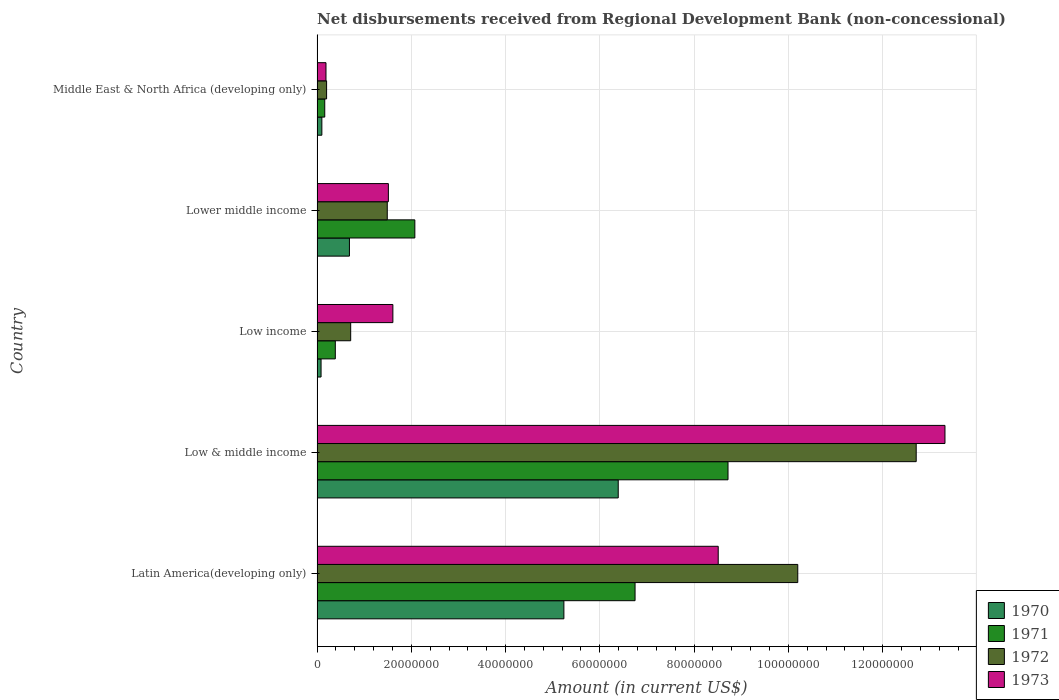How many groups of bars are there?
Give a very brief answer. 5. How many bars are there on the 5th tick from the top?
Provide a succinct answer. 4. What is the amount of disbursements received from Regional Development Bank in 1970 in Lower middle income?
Your response must be concise. 6.87e+06. Across all countries, what is the maximum amount of disbursements received from Regional Development Bank in 1970?
Make the answer very short. 6.39e+07. Across all countries, what is the minimum amount of disbursements received from Regional Development Bank in 1973?
Ensure brevity in your answer.  1.90e+06. In which country was the amount of disbursements received from Regional Development Bank in 1973 maximum?
Keep it short and to the point. Low & middle income. What is the total amount of disbursements received from Regional Development Bank in 1972 in the graph?
Your answer should be compact. 2.53e+08. What is the difference between the amount of disbursements received from Regional Development Bank in 1972 in Low & middle income and that in Lower middle income?
Your answer should be compact. 1.12e+08. What is the difference between the amount of disbursements received from Regional Development Bank in 1972 in Low income and the amount of disbursements received from Regional Development Bank in 1971 in Low & middle income?
Provide a succinct answer. -8.01e+07. What is the average amount of disbursements received from Regional Development Bank in 1971 per country?
Provide a short and direct response. 3.62e+07. What is the difference between the amount of disbursements received from Regional Development Bank in 1972 and amount of disbursements received from Regional Development Bank in 1971 in Middle East & North Africa (developing only)?
Your answer should be compact. 3.89e+05. What is the ratio of the amount of disbursements received from Regional Development Bank in 1972 in Lower middle income to that in Middle East & North Africa (developing only)?
Your answer should be compact. 7.36. Is the amount of disbursements received from Regional Development Bank in 1971 in Latin America(developing only) less than that in Low & middle income?
Your response must be concise. Yes. What is the difference between the highest and the second highest amount of disbursements received from Regional Development Bank in 1972?
Make the answer very short. 2.51e+07. What is the difference between the highest and the lowest amount of disbursements received from Regional Development Bank in 1971?
Your answer should be compact. 8.56e+07. Is the sum of the amount of disbursements received from Regional Development Bank in 1973 in Low & middle income and Low income greater than the maximum amount of disbursements received from Regional Development Bank in 1970 across all countries?
Your answer should be compact. Yes. Is it the case that in every country, the sum of the amount of disbursements received from Regional Development Bank in 1971 and amount of disbursements received from Regional Development Bank in 1970 is greater than the sum of amount of disbursements received from Regional Development Bank in 1973 and amount of disbursements received from Regional Development Bank in 1972?
Offer a very short reply. No. Is it the case that in every country, the sum of the amount of disbursements received from Regional Development Bank in 1973 and amount of disbursements received from Regional Development Bank in 1972 is greater than the amount of disbursements received from Regional Development Bank in 1970?
Offer a terse response. Yes. Are all the bars in the graph horizontal?
Offer a terse response. Yes. How many countries are there in the graph?
Make the answer very short. 5. What is the difference between two consecutive major ticks on the X-axis?
Give a very brief answer. 2.00e+07. Does the graph contain any zero values?
Keep it short and to the point. No. Where does the legend appear in the graph?
Offer a terse response. Bottom right. How many legend labels are there?
Keep it short and to the point. 4. What is the title of the graph?
Make the answer very short. Net disbursements received from Regional Development Bank (non-concessional). What is the Amount (in current US$) in 1970 in Latin America(developing only)?
Provide a short and direct response. 5.24e+07. What is the Amount (in current US$) of 1971 in Latin America(developing only)?
Offer a terse response. 6.75e+07. What is the Amount (in current US$) of 1972 in Latin America(developing only)?
Ensure brevity in your answer.  1.02e+08. What is the Amount (in current US$) of 1973 in Latin America(developing only)?
Provide a short and direct response. 8.51e+07. What is the Amount (in current US$) of 1970 in Low & middle income?
Provide a succinct answer. 6.39e+07. What is the Amount (in current US$) in 1971 in Low & middle income?
Provide a succinct answer. 8.72e+07. What is the Amount (in current US$) of 1972 in Low & middle income?
Keep it short and to the point. 1.27e+08. What is the Amount (in current US$) in 1973 in Low & middle income?
Your answer should be compact. 1.33e+08. What is the Amount (in current US$) in 1970 in Low income?
Make the answer very short. 8.50e+05. What is the Amount (in current US$) in 1971 in Low income?
Make the answer very short. 3.88e+06. What is the Amount (in current US$) of 1972 in Low income?
Your answer should be very brief. 7.14e+06. What is the Amount (in current US$) of 1973 in Low income?
Provide a succinct answer. 1.61e+07. What is the Amount (in current US$) of 1970 in Lower middle income?
Provide a succinct answer. 6.87e+06. What is the Amount (in current US$) of 1971 in Lower middle income?
Your answer should be very brief. 2.08e+07. What is the Amount (in current US$) of 1972 in Lower middle income?
Provide a short and direct response. 1.49e+07. What is the Amount (in current US$) of 1973 in Lower middle income?
Keep it short and to the point. 1.51e+07. What is the Amount (in current US$) in 1970 in Middle East & North Africa (developing only)?
Make the answer very short. 1.02e+06. What is the Amount (in current US$) of 1971 in Middle East & North Africa (developing only)?
Your response must be concise. 1.64e+06. What is the Amount (in current US$) of 1972 in Middle East & North Africa (developing only)?
Give a very brief answer. 2.02e+06. What is the Amount (in current US$) in 1973 in Middle East & North Africa (developing only)?
Give a very brief answer. 1.90e+06. Across all countries, what is the maximum Amount (in current US$) in 1970?
Make the answer very short. 6.39e+07. Across all countries, what is the maximum Amount (in current US$) of 1971?
Provide a short and direct response. 8.72e+07. Across all countries, what is the maximum Amount (in current US$) in 1972?
Your answer should be compact. 1.27e+08. Across all countries, what is the maximum Amount (in current US$) of 1973?
Keep it short and to the point. 1.33e+08. Across all countries, what is the minimum Amount (in current US$) in 1970?
Your answer should be very brief. 8.50e+05. Across all countries, what is the minimum Amount (in current US$) of 1971?
Offer a terse response. 1.64e+06. Across all countries, what is the minimum Amount (in current US$) of 1972?
Offer a terse response. 2.02e+06. Across all countries, what is the minimum Amount (in current US$) in 1973?
Offer a terse response. 1.90e+06. What is the total Amount (in current US$) of 1970 in the graph?
Your answer should be very brief. 1.25e+08. What is the total Amount (in current US$) of 1971 in the graph?
Offer a terse response. 1.81e+08. What is the total Amount (in current US$) of 1972 in the graph?
Offer a very short reply. 2.53e+08. What is the total Amount (in current US$) of 1973 in the graph?
Make the answer very short. 2.51e+08. What is the difference between the Amount (in current US$) of 1970 in Latin America(developing only) and that in Low & middle income?
Offer a terse response. -1.15e+07. What is the difference between the Amount (in current US$) in 1971 in Latin America(developing only) and that in Low & middle income?
Keep it short and to the point. -1.97e+07. What is the difference between the Amount (in current US$) of 1972 in Latin America(developing only) and that in Low & middle income?
Offer a very short reply. -2.51e+07. What is the difference between the Amount (in current US$) of 1973 in Latin America(developing only) and that in Low & middle income?
Your answer should be very brief. -4.81e+07. What is the difference between the Amount (in current US$) in 1970 in Latin America(developing only) and that in Low income?
Your answer should be very brief. 5.15e+07. What is the difference between the Amount (in current US$) of 1971 in Latin America(developing only) and that in Low income?
Your answer should be very brief. 6.36e+07. What is the difference between the Amount (in current US$) of 1972 in Latin America(developing only) and that in Low income?
Your response must be concise. 9.49e+07. What is the difference between the Amount (in current US$) in 1973 in Latin America(developing only) and that in Low income?
Ensure brevity in your answer.  6.90e+07. What is the difference between the Amount (in current US$) in 1970 in Latin America(developing only) and that in Lower middle income?
Offer a very short reply. 4.55e+07. What is the difference between the Amount (in current US$) of 1971 in Latin America(developing only) and that in Lower middle income?
Keep it short and to the point. 4.67e+07. What is the difference between the Amount (in current US$) in 1972 in Latin America(developing only) and that in Lower middle income?
Offer a very short reply. 8.71e+07. What is the difference between the Amount (in current US$) in 1973 in Latin America(developing only) and that in Lower middle income?
Give a very brief answer. 7.00e+07. What is the difference between the Amount (in current US$) in 1970 in Latin America(developing only) and that in Middle East & North Africa (developing only)?
Give a very brief answer. 5.14e+07. What is the difference between the Amount (in current US$) in 1971 in Latin America(developing only) and that in Middle East & North Africa (developing only)?
Your answer should be very brief. 6.58e+07. What is the difference between the Amount (in current US$) of 1972 in Latin America(developing only) and that in Middle East & North Africa (developing only)?
Keep it short and to the point. 1.00e+08. What is the difference between the Amount (in current US$) of 1973 in Latin America(developing only) and that in Middle East & North Africa (developing only)?
Ensure brevity in your answer.  8.32e+07. What is the difference between the Amount (in current US$) of 1970 in Low & middle income and that in Low income?
Provide a succinct answer. 6.31e+07. What is the difference between the Amount (in current US$) of 1971 in Low & middle income and that in Low income?
Your answer should be compact. 8.33e+07. What is the difference between the Amount (in current US$) of 1972 in Low & middle income and that in Low income?
Keep it short and to the point. 1.20e+08. What is the difference between the Amount (in current US$) in 1973 in Low & middle income and that in Low income?
Offer a terse response. 1.17e+08. What is the difference between the Amount (in current US$) in 1970 in Low & middle income and that in Lower middle income?
Your answer should be very brief. 5.70e+07. What is the difference between the Amount (in current US$) in 1971 in Low & middle income and that in Lower middle income?
Your answer should be compact. 6.64e+07. What is the difference between the Amount (in current US$) of 1972 in Low & middle income and that in Lower middle income?
Offer a very short reply. 1.12e+08. What is the difference between the Amount (in current US$) of 1973 in Low & middle income and that in Lower middle income?
Offer a very short reply. 1.18e+08. What is the difference between the Amount (in current US$) in 1970 in Low & middle income and that in Middle East & North Africa (developing only)?
Give a very brief answer. 6.29e+07. What is the difference between the Amount (in current US$) in 1971 in Low & middle income and that in Middle East & North Africa (developing only)?
Offer a terse response. 8.56e+07. What is the difference between the Amount (in current US$) in 1972 in Low & middle income and that in Middle East & North Africa (developing only)?
Provide a short and direct response. 1.25e+08. What is the difference between the Amount (in current US$) of 1973 in Low & middle income and that in Middle East & North Africa (developing only)?
Your answer should be compact. 1.31e+08. What is the difference between the Amount (in current US$) of 1970 in Low income and that in Lower middle income?
Make the answer very short. -6.02e+06. What is the difference between the Amount (in current US$) in 1971 in Low income and that in Lower middle income?
Offer a terse response. -1.69e+07. What is the difference between the Amount (in current US$) of 1972 in Low income and that in Lower middle income?
Provide a succinct answer. -7.76e+06. What is the difference between the Amount (in current US$) of 1973 in Low income and that in Lower middle income?
Keep it short and to the point. 9.55e+05. What is the difference between the Amount (in current US$) of 1970 in Low income and that in Middle East & North Africa (developing only)?
Your answer should be very brief. -1.71e+05. What is the difference between the Amount (in current US$) in 1971 in Low income and that in Middle East & North Africa (developing only)?
Make the answer very short. 2.24e+06. What is the difference between the Amount (in current US$) in 1972 in Low income and that in Middle East & North Africa (developing only)?
Your answer should be compact. 5.11e+06. What is the difference between the Amount (in current US$) in 1973 in Low income and that in Middle East & North Africa (developing only)?
Offer a very short reply. 1.42e+07. What is the difference between the Amount (in current US$) in 1970 in Lower middle income and that in Middle East & North Africa (developing only)?
Make the answer very short. 5.85e+06. What is the difference between the Amount (in current US$) in 1971 in Lower middle income and that in Middle East & North Africa (developing only)?
Offer a terse response. 1.91e+07. What is the difference between the Amount (in current US$) in 1972 in Lower middle income and that in Middle East & North Africa (developing only)?
Provide a short and direct response. 1.29e+07. What is the difference between the Amount (in current US$) in 1973 in Lower middle income and that in Middle East & North Africa (developing only)?
Provide a short and direct response. 1.32e+07. What is the difference between the Amount (in current US$) in 1970 in Latin America(developing only) and the Amount (in current US$) in 1971 in Low & middle income?
Your answer should be compact. -3.48e+07. What is the difference between the Amount (in current US$) of 1970 in Latin America(developing only) and the Amount (in current US$) of 1972 in Low & middle income?
Ensure brevity in your answer.  -7.48e+07. What is the difference between the Amount (in current US$) of 1970 in Latin America(developing only) and the Amount (in current US$) of 1973 in Low & middle income?
Provide a succinct answer. -8.09e+07. What is the difference between the Amount (in current US$) of 1971 in Latin America(developing only) and the Amount (in current US$) of 1972 in Low & middle income?
Make the answer very short. -5.97e+07. What is the difference between the Amount (in current US$) of 1971 in Latin America(developing only) and the Amount (in current US$) of 1973 in Low & middle income?
Your answer should be very brief. -6.58e+07. What is the difference between the Amount (in current US$) of 1972 in Latin America(developing only) and the Amount (in current US$) of 1973 in Low & middle income?
Ensure brevity in your answer.  -3.12e+07. What is the difference between the Amount (in current US$) of 1970 in Latin America(developing only) and the Amount (in current US$) of 1971 in Low income?
Offer a terse response. 4.85e+07. What is the difference between the Amount (in current US$) of 1970 in Latin America(developing only) and the Amount (in current US$) of 1972 in Low income?
Your answer should be compact. 4.52e+07. What is the difference between the Amount (in current US$) of 1970 in Latin America(developing only) and the Amount (in current US$) of 1973 in Low income?
Provide a short and direct response. 3.63e+07. What is the difference between the Amount (in current US$) in 1971 in Latin America(developing only) and the Amount (in current US$) in 1972 in Low income?
Ensure brevity in your answer.  6.03e+07. What is the difference between the Amount (in current US$) in 1971 in Latin America(developing only) and the Amount (in current US$) in 1973 in Low income?
Offer a terse response. 5.14e+07. What is the difference between the Amount (in current US$) in 1972 in Latin America(developing only) and the Amount (in current US$) in 1973 in Low income?
Keep it short and to the point. 8.59e+07. What is the difference between the Amount (in current US$) of 1970 in Latin America(developing only) and the Amount (in current US$) of 1971 in Lower middle income?
Your response must be concise. 3.16e+07. What is the difference between the Amount (in current US$) of 1970 in Latin America(developing only) and the Amount (in current US$) of 1972 in Lower middle income?
Offer a terse response. 3.75e+07. What is the difference between the Amount (in current US$) in 1970 in Latin America(developing only) and the Amount (in current US$) in 1973 in Lower middle income?
Your response must be concise. 3.72e+07. What is the difference between the Amount (in current US$) of 1971 in Latin America(developing only) and the Amount (in current US$) of 1972 in Lower middle income?
Provide a succinct answer. 5.26e+07. What is the difference between the Amount (in current US$) in 1971 in Latin America(developing only) and the Amount (in current US$) in 1973 in Lower middle income?
Provide a short and direct response. 5.23e+07. What is the difference between the Amount (in current US$) in 1972 in Latin America(developing only) and the Amount (in current US$) in 1973 in Lower middle income?
Your answer should be very brief. 8.69e+07. What is the difference between the Amount (in current US$) in 1970 in Latin America(developing only) and the Amount (in current US$) in 1971 in Middle East & North Africa (developing only)?
Offer a terse response. 5.07e+07. What is the difference between the Amount (in current US$) in 1970 in Latin America(developing only) and the Amount (in current US$) in 1972 in Middle East & North Africa (developing only)?
Provide a short and direct response. 5.04e+07. What is the difference between the Amount (in current US$) in 1970 in Latin America(developing only) and the Amount (in current US$) in 1973 in Middle East & North Africa (developing only)?
Your answer should be very brief. 5.05e+07. What is the difference between the Amount (in current US$) of 1971 in Latin America(developing only) and the Amount (in current US$) of 1972 in Middle East & North Africa (developing only)?
Offer a very short reply. 6.55e+07. What is the difference between the Amount (in current US$) in 1971 in Latin America(developing only) and the Amount (in current US$) in 1973 in Middle East & North Africa (developing only)?
Offer a very short reply. 6.56e+07. What is the difference between the Amount (in current US$) of 1972 in Latin America(developing only) and the Amount (in current US$) of 1973 in Middle East & North Africa (developing only)?
Give a very brief answer. 1.00e+08. What is the difference between the Amount (in current US$) of 1970 in Low & middle income and the Amount (in current US$) of 1971 in Low income?
Make the answer very short. 6.00e+07. What is the difference between the Amount (in current US$) of 1970 in Low & middle income and the Amount (in current US$) of 1972 in Low income?
Offer a very short reply. 5.68e+07. What is the difference between the Amount (in current US$) in 1970 in Low & middle income and the Amount (in current US$) in 1973 in Low income?
Offer a very short reply. 4.78e+07. What is the difference between the Amount (in current US$) in 1971 in Low & middle income and the Amount (in current US$) in 1972 in Low income?
Keep it short and to the point. 8.01e+07. What is the difference between the Amount (in current US$) of 1971 in Low & middle income and the Amount (in current US$) of 1973 in Low income?
Make the answer very short. 7.11e+07. What is the difference between the Amount (in current US$) of 1972 in Low & middle income and the Amount (in current US$) of 1973 in Low income?
Give a very brief answer. 1.11e+08. What is the difference between the Amount (in current US$) of 1970 in Low & middle income and the Amount (in current US$) of 1971 in Lower middle income?
Your response must be concise. 4.32e+07. What is the difference between the Amount (in current US$) in 1970 in Low & middle income and the Amount (in current US$) in 1972 in Lower middle income?
Provide a succinct answer. 4.90e+07. What is the difference between the Amount (in current US$) of 1970 in Low & middle income and the Amount (in current US$) of 1973 in Lower middle income?
Offer a terse response. 4.88e+07. What is the difference between the Amount (in current US$) in 1971 in Low & middle income and the Amount (in current US$) in 1972 in Lower middle income?
Give a very brief answer. 7.23e+07. What is the difference between the Amount (in current US$) in 1971 in Low & middle income and the Amount (in current US$) in 1973 in Lower middle income?
Ensure brevity in your answer.  7.21e+07. What is the difference between the Amount (in current US$) of 1972 in Low & middle income and the Amount (in current US$) of 1973 in Lower middle income?
Provide a short and direct response. 1.12e+08. What is the difference between the Amount (in current US$) of 1970 in Low & middle income and the Amount (in current US$) of 1971 in Middle East & North Africa (developing only)?
Your answer should be compact. 6.23e+07. What is the difference between the Amount (in current US$) in 1970 in Low & middle income and the Amount (in current US$) in 1972 in Middle East & North Africa (developing only)?
Your response must be concise. 6.19e+07. What is the difference between the Amount (in current US$) of 1970 in Low & middle income and the Amount (in current US$) of 1973 in Middle East & North Africa (developing only)?
Offer a very short reply. 6.20e+07. What is the difference between the Amount (in current US$) in 1971 in Low & middle income and the Amount (in current US$) in 1972 in Middle East & North Africa (developing only)?
Make the answer very short. 8.52e+07. What is the difference between the Amount (in current US$) of 1971 in Low & middle income and the Amount (in current US$) of 1973 in Middle East & North Africa (developing only)?
Keep it short and to the point. 8.53e+07. What is the difference between the Amount (in current US$) of 1972 in Low & middle income and the Amount (in current US$) of 1973 in Middle East & North Africa (developing only)?
Keep it short and to the point. 1.25e+08. What is the difference between the Amount (in current US$) in 1970 in Low income and the Amount (in current US$) in 1971 in Lower middle income?
Offer a terse response. -1.99e+07. What is the difference between the Amount (in current US$) of 1970 in Low income and the Amount (in current US$) of 1972 in Lower middle income?
Ensure brevity in your answer.  -1.40e+07. What is the difference between the Amount (in current US$) in 1970 in Low income and the Amount (in current US$) in 1973 in Lower middle income?
Provide a short and direct response. -1.43e+07. What is the difference between the Amount (in current US$) in 1971 in Low income and the Amount (in current US$) in 1972 in Lower middle income?
Make the answer very short. -1.10e+07. What is the difference between the Amount (in current US$) in 1971 in Low income and the Amount (in current US$) in 1973 in Lower middle income?
Provide a short and direct response. -1.13e+07. What is the difference between the Amount (in current US$) in 1972 in Low income and the Amount (in current US$) in 1973 in Lower middle income?
Offer a very short reply. -8.00e+06. What is the difference between the Amount (in current US$) in 1970 in Low income and the Amount (in current US$) in 1971 in Middle East & North Africa (developing only)?
Ensure brevity in your answer.  -7.85e+05. What is the difference between the Amount (in current US$) of 1970 in Low income and the Amount (in current US$) of 1972 in Middle East & North Africa (developing only)?
Provide a short and direct response. -1.17e+06. What is the difference between the Amount (in current US$) in 1970 in Low income and the Amount (in current US$) in 1973 in Middle East & North Africa (developing only)?
Your answer should be compact. -1.05e+06. What is the difference between the Amount (in current US$) in 1971 in Low income and the Amount (in current US$) in 1972 in Middle East & North Africa (developing only)?
Offer a terse response. 1.85e+06. What is the difference between the Amount (in current US$) in 1971 in Low income and the Amount (in current US$) in 1973 in Middle East & North Africa (developing only)?
Your response must be concise. 1.98e+06. What is the difference between the Amount (in current US$) in 1972 in Low income and the Amount (in current US$) in 1973 in Middle East & North Africa (developing only)?
Give a very brief answer. 5.24e+06. What is the difference between the Amount (in current US$) of 1970 in Lower middle income and the Amount (in current US$) of 1971 in Middle East & North Africa (developing only)?
Make the answer very short. 5.24e+06. What is the difference between the Amount (in current US$) in 1970 in Lower middle income and the Amount (in current US$) in 1972 in Middle East & North Africa (developing only)?
Provide a succinct answer. 4.85e+06. What is the difference between the Amount (in current US$) of 1970 in Lower middle income and the Amount (in current US$) of 1973 in Middle East & North Africa (developing only)?
Provide a short and direct response. 4.98e+06. What is the difference between the Amount (in current US$) in 1971 in Lower middle income and the Amount (in current US$) in 1972 in Middle East & North Africa (developing only)?
Offer a terse response. 1.87e+07. What is the difference between the Amount (in current US$) in 1971 in Lower middle income and the Amount (in current US$) in 1973 in Middle East & North Africa (developing only)?
Offer a very short reply. 1.89e+07. What is the difference between the Amount (in current US$) of 1972 in Lower middle income and the Amount (in current US$) of 1973 in Middle East & North Africa (developing only)?
Offer a terse response. 1.30e+07. What is the average Amount (in current US$) in 1970 per country?
Make the answer very short. 2.50e+07. What is the average Amount (in current US$) of 1971 per country?
Your response must be concise. 3.62e+07. What is the average Amount (in current US$) of 1972 per country?
Offer a terse response. 5.06e+07. What is the average Amount (in current US$) of 1973 per country?
Ensure brevity in your answer.  5.03e+07. What is the difference between the Amount (in current US$) of 1970 and Amount (in current US$) of 1971 in Latin America(developing only)?
Ensure brevity in your answer.  -1.51e+07. What is the difference between the Amount (in current US$) of 1970 and Amount (in current US$) of 1972 in Latin America(developing only)?
Provide a short and direct response. -4.96e+07. What is the difference between the Amount (in current US$) of 1970 and Amount (in current US$) of 1973 in Latin America(developing only)?
Give a very brief answer. -3.27e+07. What is the difference between the Amount (in current US$) in 1971 and Amount (in current US$) in 1972 in Latin America(developing only)?
Your answer should be compact. -3.45e+07. What is the difference between the Amount (in current US$) of 1971 and Amount (in current US$) of 1973 in Latin America(developing only)?
Provide a succinct answer. -1.76e+07. What is the difference between the Amount (in current US$) in 1972 and Amount (in current US$) in 1973 in Latin America(developing only)?
Your answer should be compact. 1.69e+07. What is the difference between the Amount (in current US$) in 1970 and Amount (in current US$) in 1971 in Low & middle income?
Ensure brevity in your answer.  -2.33e+07. What is the difference between the Amount (in current US$) of 1970 and Amount (in current US$) of 1972 in Low & middle income?
Provide a succinct answer. -6.32e+07. What is the difference between the Amount (in current US$) of 1970 and Amount (in current US$) of 1973 in Low & middle income?
Your answer should be very brief. -6.93e+07. What is the difference between the Amount (in current US$) of 1971 and Amount (in current US$) of 1972 in Low & middle income?
Give a very brief answer. -3.99e+07. What is the difference between the Amount (in current US$) of 1971 and Amount (in current US$) of 1973 in Low & middle income?
Provide a succinct answer. -4.60e+07. What is the difference between the Amount (in current US$) in 1972 and Amount (in current US$) in 1973 in Low & middle income?
Your response must be concise. -6.10e+06. What is the difference between the Amount (in current US$) of 1970 and Amount (in current US$) of 1971 in Low income?
Your answer should be compact. -3.02e+06. What is the difference between the Amount (in current US$) in 1970 and Amount (in current US$) in 1972 in Low income?
Offer a terse response. -6.29e+06. What is the difference between the Amount (in current US$) in 1970 and Amount (in current US$) in 1973 in Low income?
Offer a terse response. -1.52e+07. What is the difference between the Amount (in current US$) in 1971 and Amount (in current US$) in 1972 in Low income?
Your answer should be very brief. -3.26e+06. What is the difference between the Amount (in current US$) of 1971 and Amount (in current US$) of 1973 in Low income?
Provide a short and direct response. -1.22e+07. What is the difference between the Amount (in current US$) in 1972 and Amount (in current US$) in 1973 in Low income?
Ensure brevity in your answer.  -8.95e+06. What is the difference between the Amount (in current US$) of 1970 and Amount (in current US$) of 1971 in Lower middle income?
Offer a terse response. -1.39e+07. What is the difference between the Amount (in current US$) of 1970 and Amount (in current US$) of 1972 in Lower middle income?
Provide a short and direct response. -8.03e+06. What is the difference between the Amount (in current US$) in 1970 and Amount (in current US$) in 1973 in Lower middle income?
Keep it short and to the point. -8.26e+06. What is the difference between the Amount (in current US$) in 1971 and Amount (in current US$) in 1972 in Lower middle income?
Your response must be concise. 5.85e+06. What is the difference between the Amount (in current US$) of 1971 and Amount (in current US$) of 1973 in Lower middle income?
Provide a short and direct response. 5.62e+06. What is the difference between the Amount (in current US$) in 1972 and Amount (in current US$) in 1973 in Lower middle income?
Provide a succinct answer. -2.36e+05. What is the difference between the Amount (in current US$) of 1970 and Amount (in current US$) of 1971 in Middle East & North Africa (developing only)?
Give a very brief answer. -6.14e+05. What is the difference between the Amount (in current US$) of 1970 and Amount (in current US$) of 1972 in Middle East & North Africa (developing only)?
Your answer should be very brief. -1.00e+06. What is the difference between the Amount (in current US$) in 1970 and Amount (in current US$) in 1973 in Middle East & North Africa (developing only)?
Provide a short and direct response. -8.75e+05. What is the difference between the Amount (in current US$) of 1971 and Amount (in current US$) of 1972 in Middle East & North Africa (developing only)?
Your answer should be very brief. -3.89e+05. What is the difference between the Amount (in current US$) in 1971 and Amount (in current US$) in 1973 in Middle East & North Africa (developing only)?
Make the answer very short. -2.61e+05. What is the difference between the Amount (in current US$) of 1972 and Amount (in current US$) of 1973 in Middle East & North Africa (developing only)?
Provide a succinct answer. 1.28e+05. What is the ratio of the Amount (in current US$) of 1970 in Latin America(developing only) to that in Low & middle income?
Give a very brief answer. 0.82. What is the ratio of the Amount (in current US$) of 1971 in Latin America(developing only) to that in Low & middle income?
Offer a very short reply. 0.77. What is the ratio of the Amount (in current US$) of 1972 in Latin America(developing only) to that in Low & middle income?
Make the answer very short. 0.8. What is the ratio of the Amount (in current US$) of 1973 in Latin America(developing only) to that in Low & middle income?
Provide a succinct answer. 0.64. What is the ratio of the Amount (in current US$) of 1970 in Latin America(developing only) to that in Low income?
Provide a short and direct response. 61.62. What is the ratio of the Amount (in current US$) of 1971 in Latin America(developing only) to that in Low income?
Your response must be concise. 17.41. What is the ratio of the Amount (in current US$) in 1972 in Latin America(developing only) to that in Low income?
Your answer should be compact. 14.29. What is the ratio of the Amount (in current US$) in 1973 in Latin America(developing only) to that in Low income?
Provide a short and direct response. 5.29. What is the ratio of the Amount (in current US$) in 1970 in Latin America(developing only) to that in Lower middle income?
Your response must be concise. 7.62. What is the ratio of the Amount (in current US$) in 1971 in Latin America(developing only) to that in Lower middle income?
Your response must be concise. 3.25. What is the ratio of the Amount (in current US$) of 1972 in Latin America(developing only) to that in Lower middle income?
Give a very brief answer. 6.85. What is the ratio of the Amount (in current US$) of 1973 in Latin America(developing only) to that in Lower middle income?
Make the answer very short. 5.62. What is the ratio of the Amount (in current US$) in 1970 in Latin America(developing only) to that in Middle East & North Africa (developing only)?
Provide a succinct answer. 51.3. What is the ratio of the Amount (in current US$) in 1971 in Latin America(developing only) to that in Middle East & North Africa (developing only)?
Keep it short and to the point. 41.27. What is the ratio of the Amount (in current US$) in 1972 in Latin America(developing only) to that in Middle East & North Africa (developing only)?
Ensure brevity in your answer.  50.4. What is the ratio of the Amount (in current US$) of 1973 in Latin America(developing only) to that in Middle East & North Africa (developing only)?
Make the answer very short. 44.9. What is the ratio of the Amount (in current US$) in 1970 in Low & middle income to that in Low income?
Provide a short and direct response. 75.18. What is the ratio of the Amount (in current US$) of 1971 in Low & middle income to that in Low income?
Give a very brief answer. 22.5. What is the ratio of the Amount (in current US$) of 1972 in Low & middle income to that in Low income?
Ensure brevity in your answer.  17.81. What is the ratio of the Amount (in current US$) in 1973 in Low & middle income to that in Low income?
Keep it short and to the point. 8.28. What is the ratio of the Amount (in current US$) of 1970 in Low & middle income to that in Lower middle income?
Give a very brief answer. 9.3. What is the ratio of the Amount (in current US$) of 1971 in Low & middle income to that in Lower middle income?
Ensure brevity in your answer.  4.2. What is the ratio of the Amount (in current US$) in 1972 in Low & middle income to that in Lower middle income?
Offer a terse response. 8.53. What is the ratio of the Amount (in current US$) of 1973 in Low & middle income to that in Lower middle income?
Your answer should be compact. 8.8. What is the ratio of the Amount (in current US$) of 1970 in Low & middle income to that in Middle East & North Africa (developing only)?
Ensure brevity in your answer.  62.59. What is the ratio of the Amount (in current US$) in 1971 in Low & middle income to that in Middle East & North Africa (developing only)?
Provide a short and direct response. 53.33. What is the ratio of the Amount (in current US$) in 1972 in Low & middle income to that in Middle East & North Africa (developing only)?
Make the answer very short. 62.81. What is the ratio of the Amount (in current US$) in 1973 in Low & middle income to that in Middle East & North Africa (developing only)?
Give a very brief answer. 70.27. What is the ratio of the Amount (in current US$) of 1970 in Low income to that in Lower middle income?
Give a very brief answer. 0.12. What is the ratio of the Amount (in current US$) of 1971 in Low income to that in Lower middle income?
Make the answer very short. 0.19. What is the ratio of the Amount (in current US$) in 1972 in Low income to that in Lower middle income?
Make the answer very short. 0.48. What is the ratio of the Amount (in current US$) in 1973 in Low income to that in Lower middle income?
Give a very brief answer. 1.06. What is the ratio of the Amount (in current US$) of 1970 in Low income to that in Middle East & North Africa (developing only)?
Your answer should be very brief. 0.83. What is the ratio of the Amount (in current US$) in 1971 in Low income to that in Middle East & North Africa (developing only)?
Your answer should be very brief. 2.37. What is the ratio of the Amount (in current US$) of 1972 in Low income to that in Middle East & North Africa (developing only)?
Offer a very short reply. 3.53. What is the ratio of the Amount (in current US$) in 1973 in Low income to that in Middle East & North Africa (developing only)?
Your answer should be compact. 8.49. What is the ratio of the Amount (in current US$) in 1970 in Lower middle income to that in Middle East & North Africa (developing only)?
Ensure brevity in your answer.  6.73. What is the ratio of the Amount (in current US$) of 1971 in Lower middle income to that in Middle East & North Africa (developing only)?
Offer a very short reply. 12.69. What is the ratio of the Amount (in current US$) of 1972 in Lower middle income to that in Middle East & North Africa (developing only)?
Provide a short and direct response. 7.36. What is the ratio of the Amount (in current US$) in 1973 in Lower middle income to that in Middle East & North Africa (developing only)?
Keep it short and to the point. 7.98. What is the difference between the highest and the second highest Amount (in current US$) in 1970?
Provide a succinct answer. 1.15e+07. What is the difference between the highest and the second highest Amount (in current US$) of 1971?
Give a very brief answer. 1.97e+07. What is the difference between the highest and the second highest Amount (in current US$) in 1972?
Ensure brevity in your answer.  2.51e+07. What is the difference between the highest and the second highest Amount (in current US$) of 1973?
Give a very brief answer. 4.81e+07. What is the difference between the highest and the lowest Amount (in current US$) in 1970?
Your answer should be very brief. 6.31e+07. What is the difference between the highest and the lowest Amount (in current US$) of 1971?
Provide a short and direct response. 8.56e+07. What is the difference between the highest and the lowest Amount (in current US$) of 1972?
Give a very brief answer. 1.25e+08. What is the difference between the highest and the lowest Amount (in current US$) in 1973?
Keep it short and to the point. 1.31e+08. 